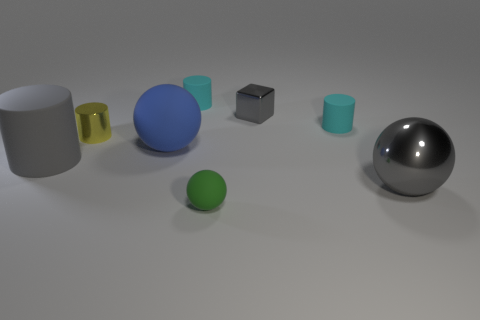Subtract 1 cylinders. How many cylinders are left? 3 Subtract all gray spheres. Subtract all blue cylinders. How many spheres are left? 2 Add 2 green metallic cubes. How many objects exist? 10 Subtract all spheres. How many objects are left? 5 Add 3 gray rubber cylinders. How many gray rubber cylinders exist? 4 Subtract 0 green cylinders. How many objects are left? 8 Subtract all green objects. Subtract all gray cylinders. How many objects are left? 6 Add 6 tiny shiny objects. How many tiny shiny objects are left? 8 